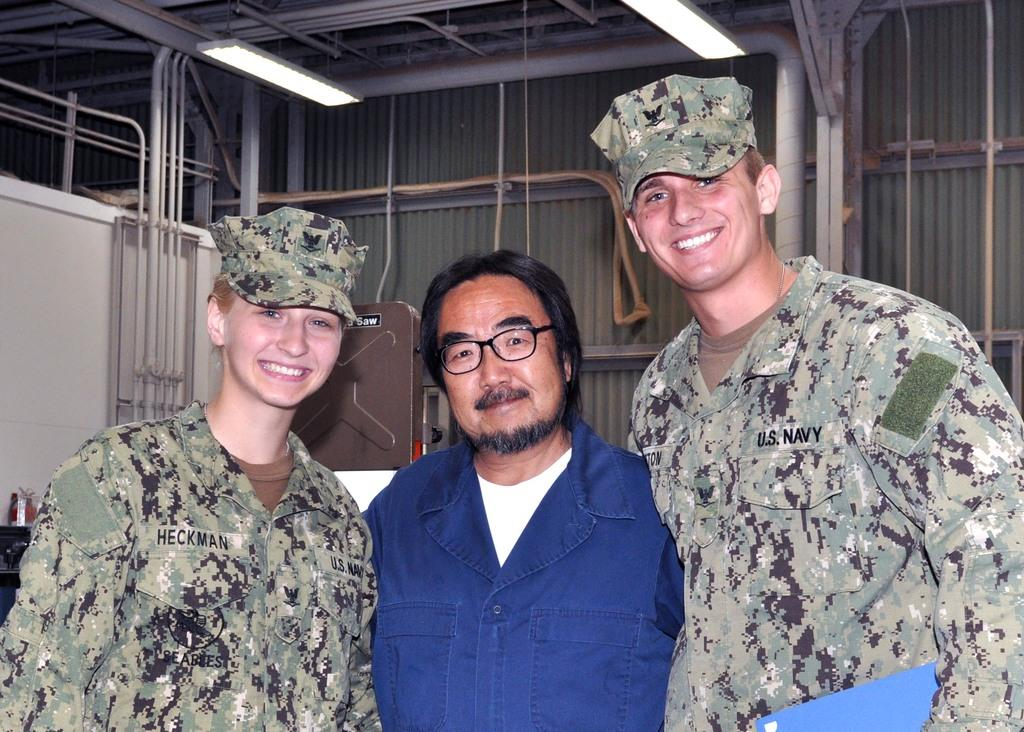How many people are present in the image? There are three persons in the image. What is located behind the persons in the image? There is a wall behind the persons in the image. What type of sack can be seen hanging on the wall in the image? There is no sack present in the image; only the wall is visible behind the persons. Can you tell me how many letters are being held by the persons in the image? There is no mention of letters or any written material in the image; the persons are not holding any such items. 